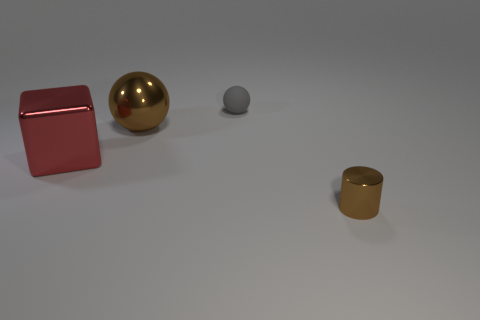Add 1 metal cubes. How many objects exist? 5 Subtract all large red shiny cubes. Subtract all cyan metal cubes. How many objects are left? 3 Add 1 tiny matte objects. How many tiny matte objects are left? 2 Add 3 brown shiny balls. How many brown shiny balls exist? 4 Subtract 0 yellow spheres. How many objects are left? 4 